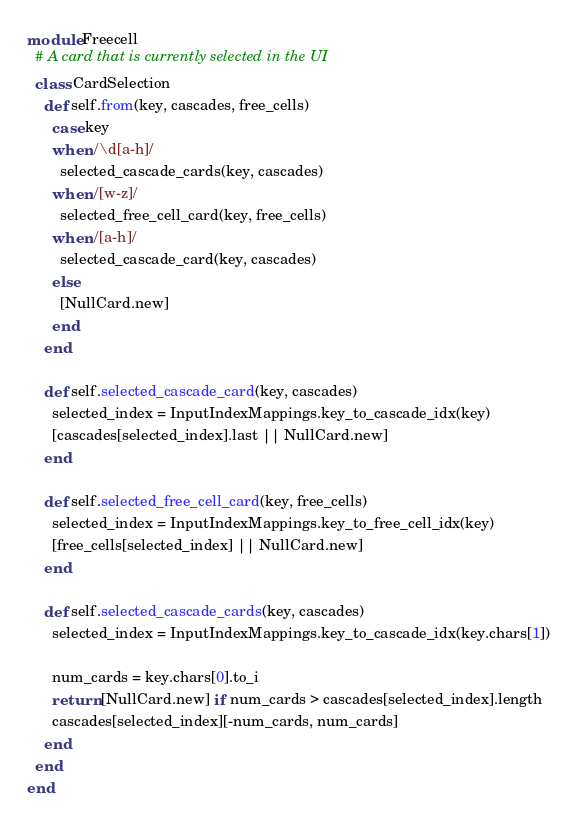Convert code to text. <code><loc_0><loc_0><loc_500><loc_500><_Ruby_>module Freecell
  # A card that is currently selected in the UI
  class CardSelection
    def self.from(key, cascades, free_cells)
      case key
      when /\d[a-h]/
        selected_cascade_cards(key, cascades)
      when /[w-z]/
        selected_free_cell_card(key, free_cells)
      when /[a-h]/
        selected_cascade_card(key, cascades)
      else
        [NullCard.new]
      end
    end

    def self.selected_cascade_card(key, cascades)
      selected_index = InputIndexMappings.key_to_cascade_idx(key)
      [cascades[selected_index].last || NullCard.new]
    end

    def self.selected_free_cell_card(key, free_cells)
      selected_index = InputIndexMappings.key_to_free_cell_idx(key)
      [free_cells[selected_index] || NullCard.new]
    end

    def self.selected_cascade_cards(key, cascades)
      selected_index = InputIndexMappings.key_to_cascade_idx(key.chars[1])

      num_cards = key.chars[0].to_i
      return [NullCard.new] if num_cards > cascades[selected_index].length
      cascades[selected_index][-num_cards, num_cards]
    end
  end
end
</code> 